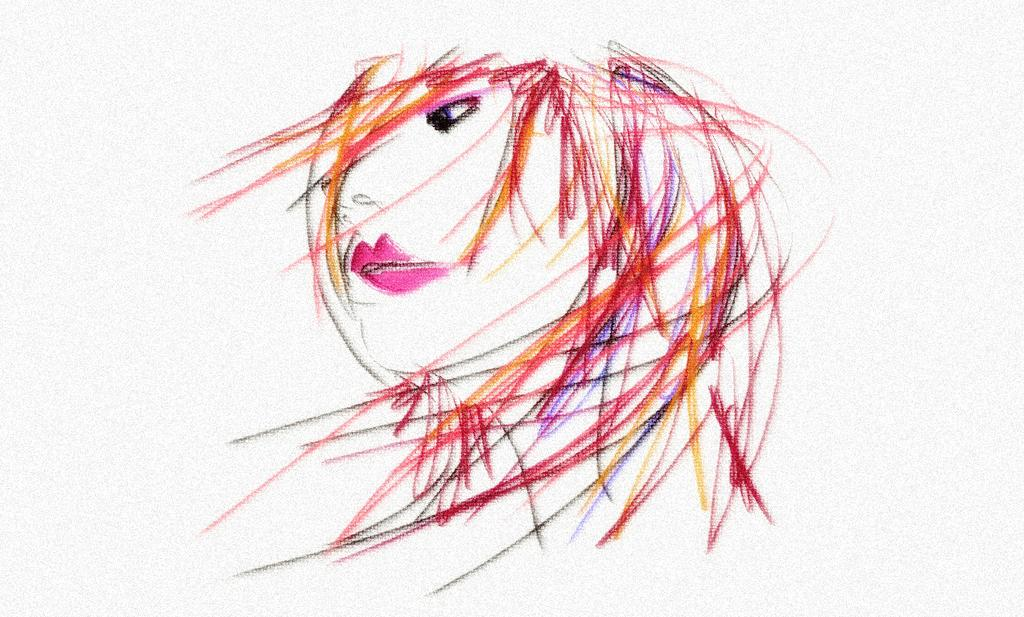What is depicted in the image? There is a painting of a person in the image. Can you describe the subject of the painting? The painting features a person, but no specific details about the person's appearance or actions are provided. What type of insurance policy does the actor on stage have in the image? There is no actor on stage or any reference to insurance in the image; it only features a painting of a person. 